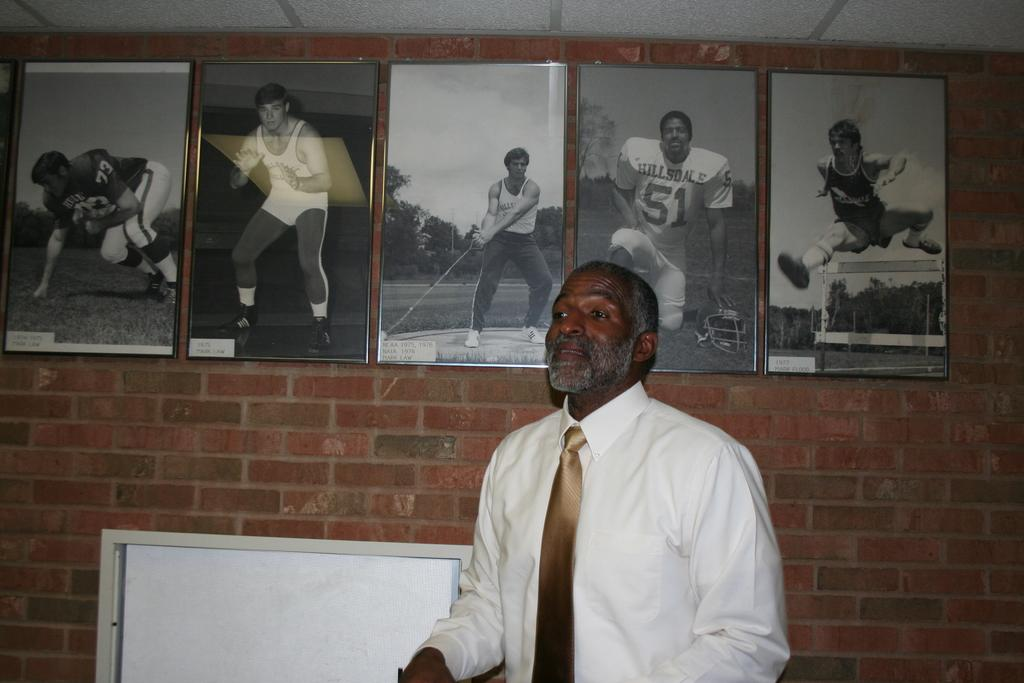Who is present in the image? There is a man in the picture. What is the man wearing? The man is wearing a white shirt. What can be seen on the wall in the background of the image? There are photo frames on the wall in the background of the image. What type of pet can be seen playing with a hole in the image? There is no pet or hole present in the image; it features a man wearing a white shirt with photo frames on the wall in the background. 